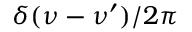Convert formula to latex. <formula><loc_0><loc_0><loc_500><loc_500>\delta ( \nu - \nu ^ { \prime } ) / 2 \pi</formula> 